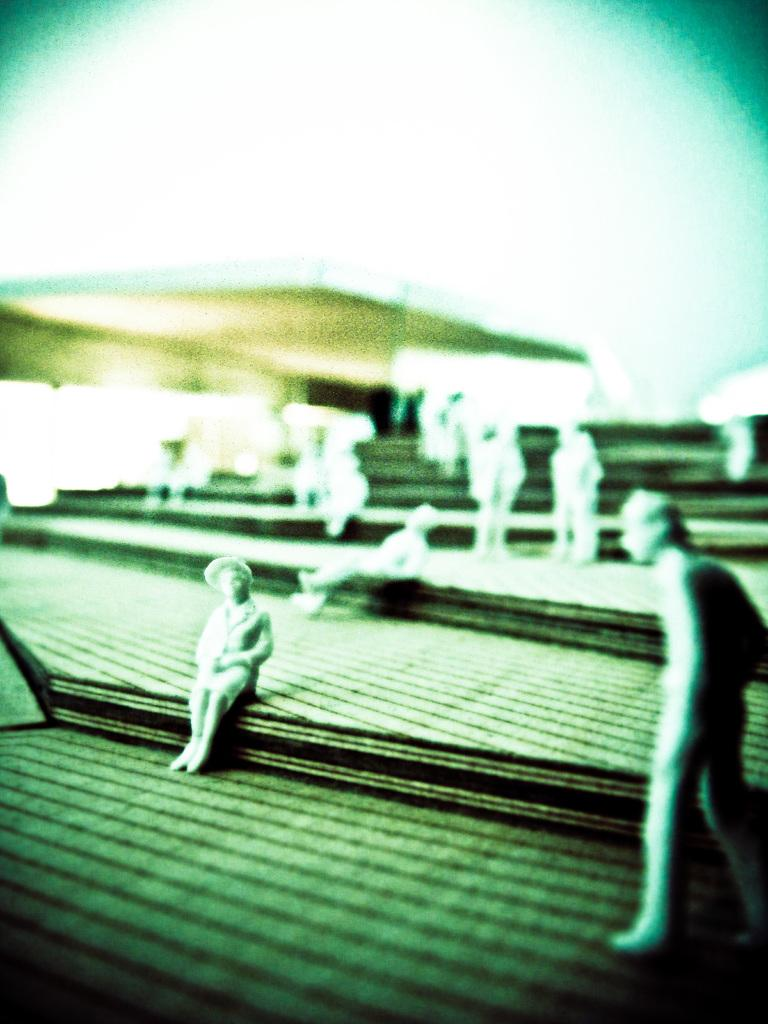What objects are present in the image? There are tiny statues in the image. How are the statues arranged? The statues are arranged on a surface. What can be observed about the background of the statues? The background of the statues is blurred. What type of car can be seen in the background of the image? There is no car present in the image; the background of the statues is blurred. How many spoons are visible in the image? There are no spoons present in the image; it features tiny statues arranged on a surface. 